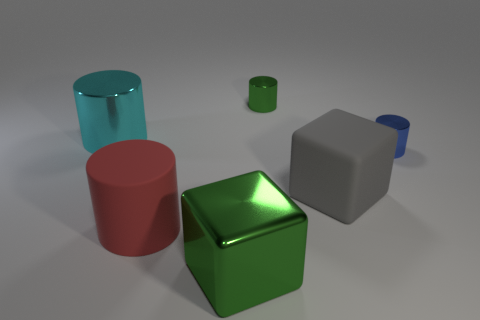Subtract all large rubber cylinders. How many cylinders are left? 3 Add 4 large red things. How many objects exist? 10 Subtract all blue cylinders. How many cylinders are left? 3 Subtract all cylinders. How many objects are left? 2 Subtract 0 yellow spheres. How many objects are left? 6 Subtract all cyan cylinders. Subtract all green spheres. How many cylinders are left? 3 Subtract all red spheres. How many gray cubes are left? 1 Subtract all large cyan cylinders. Subtract all large gray things. How many objects are left? 4 Add 2 tiny green cylinders. How many tiny green cylinders are left? 3 Add 2 large gray matte things. How many large gray matte things exist? 3 